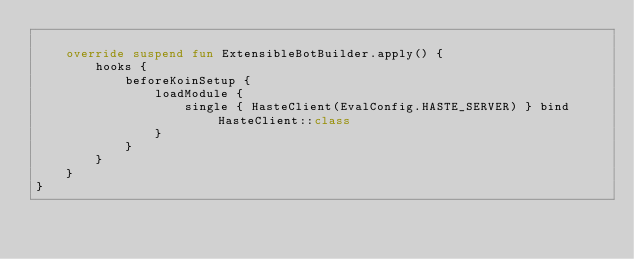<code> <loc_0><loc_0><loc_500><loc_500><_Kotlin_>
    override suspend fun ExtensibleBotBuilder.apply() {
        hooks {
            beforeKoinSetup {
                loadModule {
                    single { HasteClient(EvalConfig.HASTE_SERVER) } bind HasteClient::class
                }
            }
        }
    }
}
</code> 